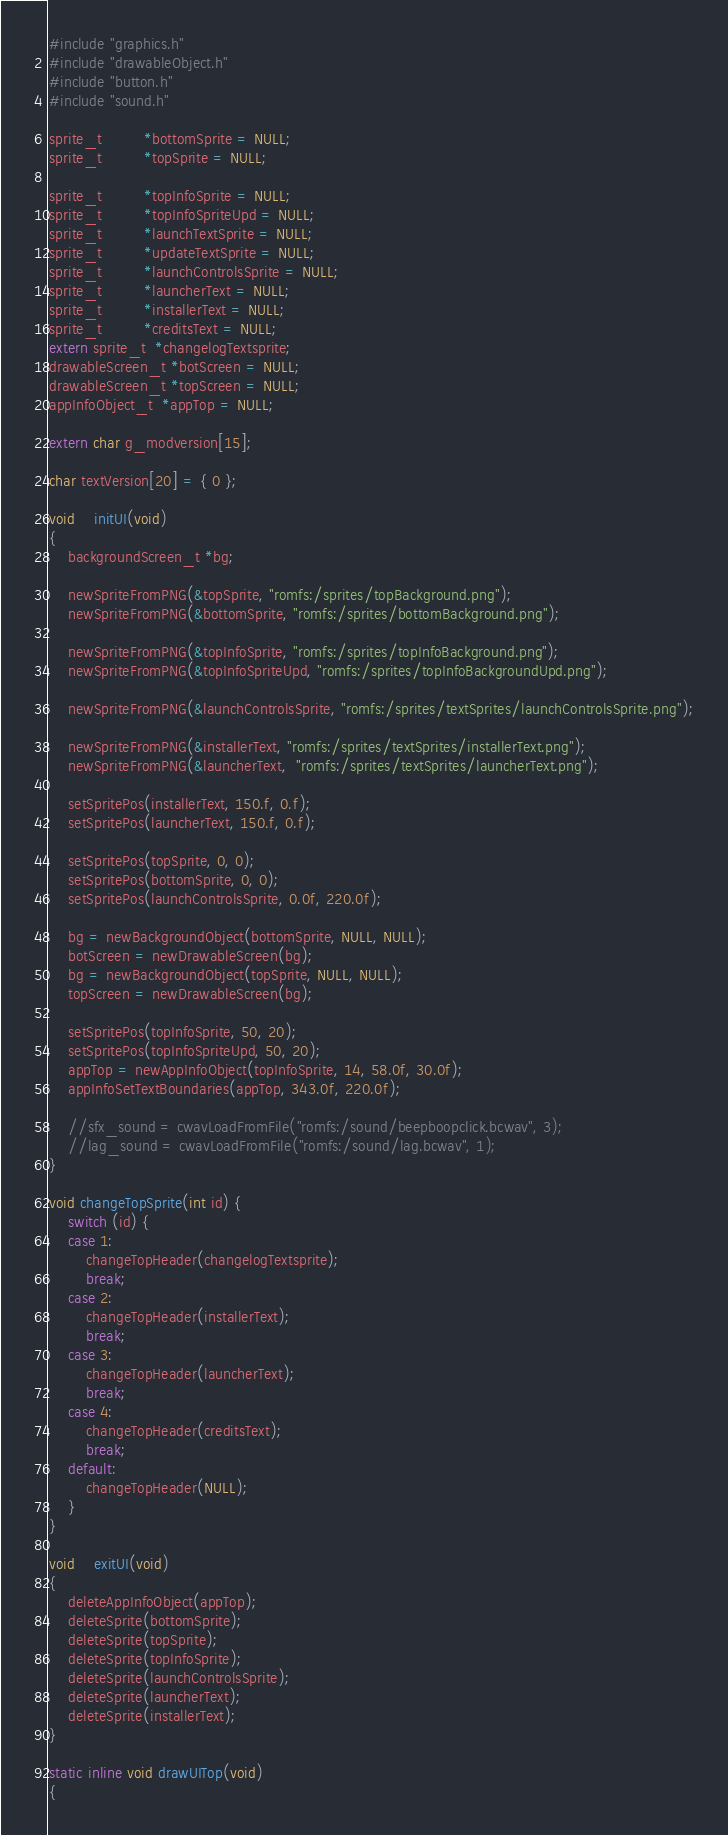Convert code to text. <code><loc_0><loc_0><loc_500><loc_500><_C_>#include "graphics.h"
#include "drawableObject.h"
#include "button.h"
#include "sound.h"

sprite_t         *bottomSprite = NULL;
sprite_t         *topSprite = NULL;

sprite_t         *topInfoSprite = NULL;
sprite_t		 *topInfoSpriteUpd = NULL;
sprite_t         *launchTextSprite = NULL;
sprite_t		 *updateTextSprite = NULL;
sprite_t         *launchControlsSprite = NULL;
sprite_t		 *launcherText = NULL;
sprite_t         *installerText = NULL;
sprite_t         *creditsText = NULL;
extern sprite_t  *changelogTextsprite;
drawableScreen_t *botScreen = NULL;
drawableScreen_t *topScreen = NULL;
appInfoObject_t  *appTop = NULL;

extern char g_modversion[15];

char textVersion[20] = { 0 };

void    initUI(void)
{
    backgroundScreen_t *bg;

    newSpriteFromPNG(&topSprite, "romfs:/sprites/topBackground.png");
    newSpriteFromPNG(&bottomSprite, "romfs:/sprites/bottomBackground.png");    

    newSpriteFromPNG(&topInfoSprite, "romfs:/sprites/topInfoBackground.png");
	newSpriteFromPNG(&topInfoSpriteUpd, "romfs:/sprites/topInfoBackgroundUpd.png");

	newSpriteFromPNG(&launchControlsSprite, "romfs:/sprites/textSprites/launchControlsSprite.png");

	newSpriteFromPNG(&installerText, "romfs:/sprites/textSprites/installerText.png");
	newSpriteFromPNG(&launcherText,  "romfs:/sprites/textSprites/launcherText.png");

	setSpritePos(installerText, 150.f, 0.f);
	setSpritePos(launcherText, 150.f, 0.f);

    setSpritePos(topSprite, 0, 0);
    setSpritePos(bottomSprite, 0, 0);
	setSpritePos(launchControlsSprite, 0.0f, 220.0f);
    
    bg = newBackgroundObject(bottomSprite, NULL, NULL);
    botScreen = newDrawableScreen(bg);
    bg = newBackgroundObject(topSprite, NULL, NULL);
    topScreen = newDrawableScreen(bg);

    setSpritePos(topInfoSprite, 50, 20);
	setSpritePos(topInfoSpriteUpd, 50, 20);
    appTop = newAppInfoObject(topInfoSprite, 14, 58.0f, 30.0f);
    appInfoSetTextBoundaries(appTop, 343.0f, 220.0f);

    //sfx_sound = cwavLoadFromFile("romfs:/sound/beepboopclick.bcwav", 3);
    //lag_sound = cwavLoadFromFile("romfs:/sound/lag.bcwav", 1);
}

void changeTopSprite(int id) {
	switch (id) {
	case 1:
		changeTopHeader(changelogTextsprite);
		break;
	case 2:
		changeTopHeader(installerText);
		break;
	case 3:
		changeTopHeader(launcherText);
		break;
	case 4:
		changeTopHeader(creditsText);
		break;
	default:
		changeTopHeader(NULL);
	}
}

void    exitUI(void)
{
    deleteAppInfoObject(appTop);
    deleteSprite(bottomSprite);
    deleteSprite(topSprite);
    deleteSprite(topInfoSprite);
	deleteSprite(launchControlsSprite);
	deleteSprite(launcherText);
	deleteSprite(installerText);
}

static inline void drawUITop(void)
{</code> 